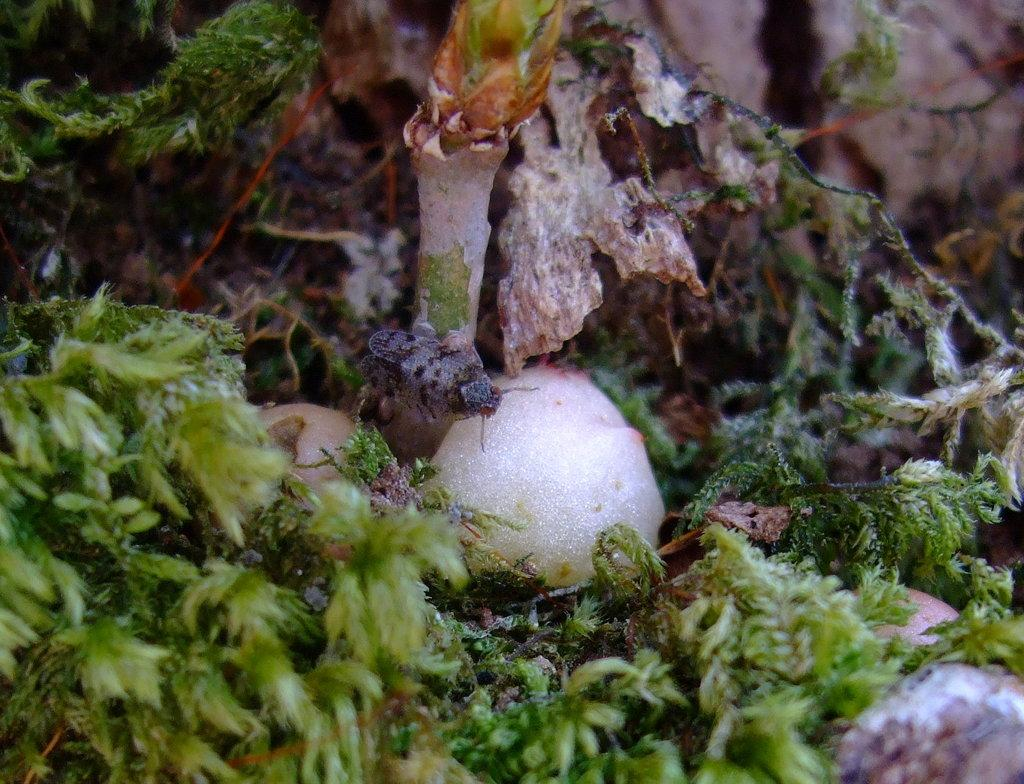What is located at the bottom of the image? There are leaves of a plant at the bottom of the image. What else can be seen in the image? There is an insect in the image. On what surface is the insect located? The insect is on a white-colored stone. Where is the woman carrying a pail in the image? There is no woman carrying a pail in the image; it only features leaves of a plant, an insect, and a white-colored stone. 